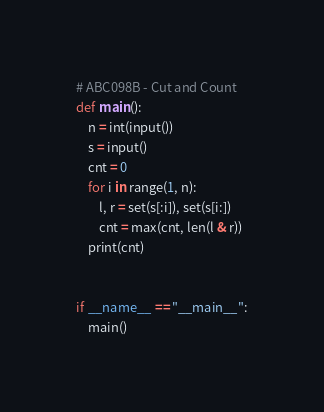Convert code to text. <code><loc_0><loc_0><loc_500><loc_500><_Python_># ABC098B - Cut and Count
def main():
    n = int(input())
    s = input()
    cnt = 0
    for i in range(1, n):
        l, r = set(s[:i]), set(s[i:])
        cnt = max(cnt, len(l & r))
    print(cnt)


if __name__ == "__main__":
    main()</code> 